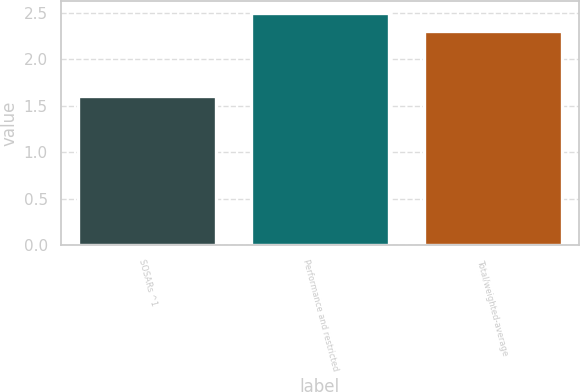Convert chart. <chart><loc_0><loc_0><loc_500><loc_500><bar_chart><fcel>SOSARs ^1<fcel>Performance and restricted<fcel>Total/weighted-average<nl><fcel>1.6<fcel>2.5<fcel>2.3<nl></chart> 